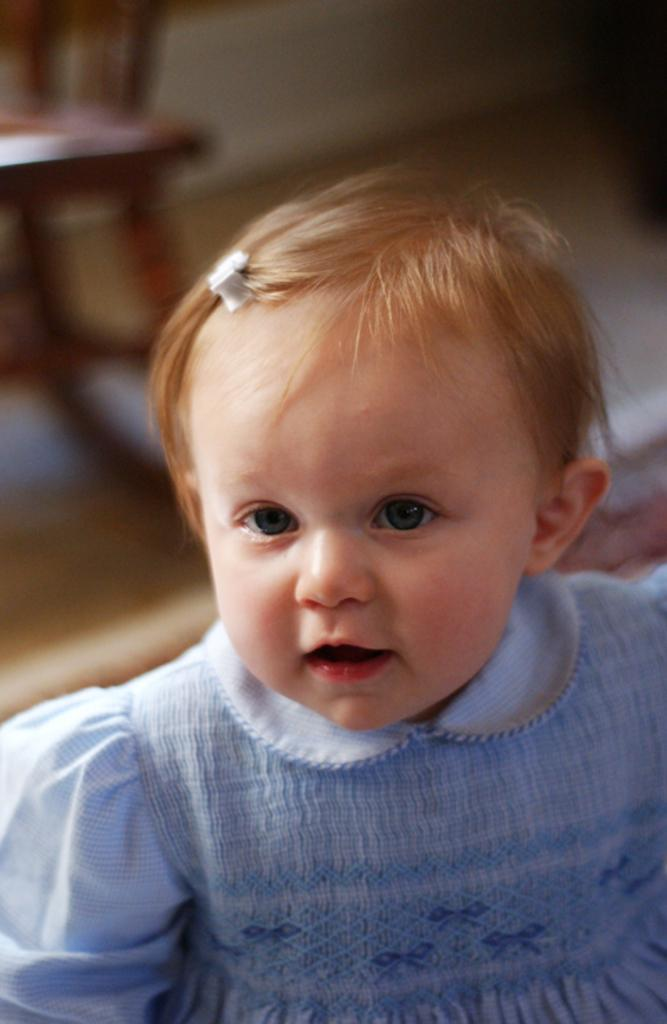Who is the main subject in the image? There is a girl in the image. What is the girl doing in the image? The girl is looking at something, and her mouth is open. Can you describe the background of the image? The background of the image is blurred. What object is present in the image that the girl might be sitting on? There is a chair in the image. What type of pin is the girl attempting to use in the image? There is no pin present in the image, and the girl is not attempting to use any pin. 